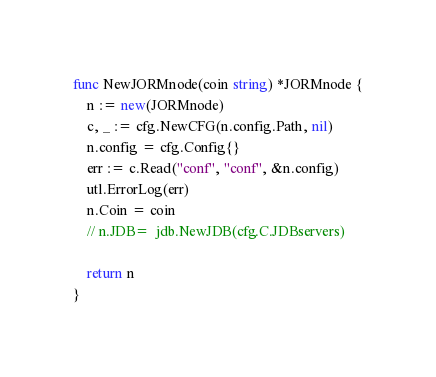Convert code to text. <code><loc_0><loc_0><loc_500><loc_500><_Go_>
func NewJORMnode(coin string) *JORMnode {
	n := new(JORMnode)
	c, _ := cfg.NewCFG(n.config.Path, nil)
	n.config = cfg.Config{}
	err := c.Read("conf", "conf", &n.config)
	utl.ErrorLog(err)
	n.Coin = coin
	// n.JDB=  jdb.NewJDB(cfg.C.JDBservers)

	return n
}
</code> 